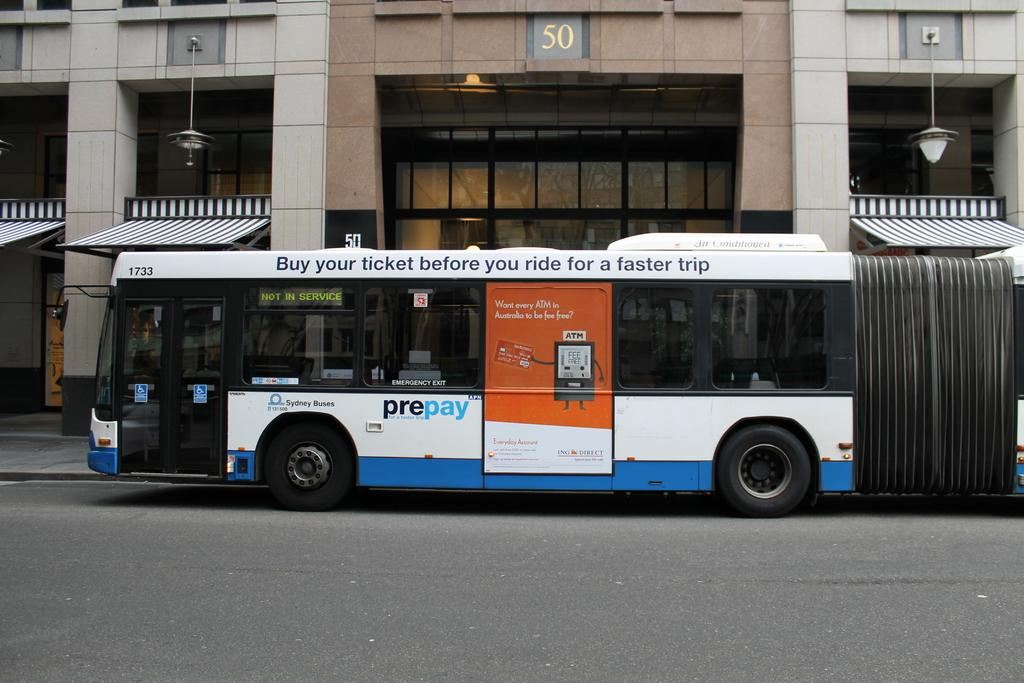<image>
Create a compact narrative representing the image presented. a bus that says 'buy your ticket before you ride for a faster trip' on the side of it 